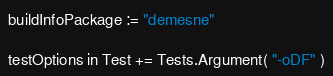Convert code to text. <code><loc_0><loc_0><loc_500><loc_500><_Scala_>
buildInfoPackage := "demesne"

testOptions in Test += Tests.Argument( "-oDF" )
</code> 